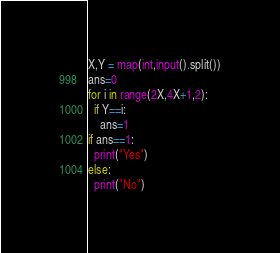<code> <loc_0><loc_0><loc_500><loc_500><_Python_>X,Y = map(int,input().split())
ans=0
for i in range(2X,4X+1,2):
  if Y==i:
    ans=1
if ans==1:
  print("Yes")
else:
  print("No")</code> 